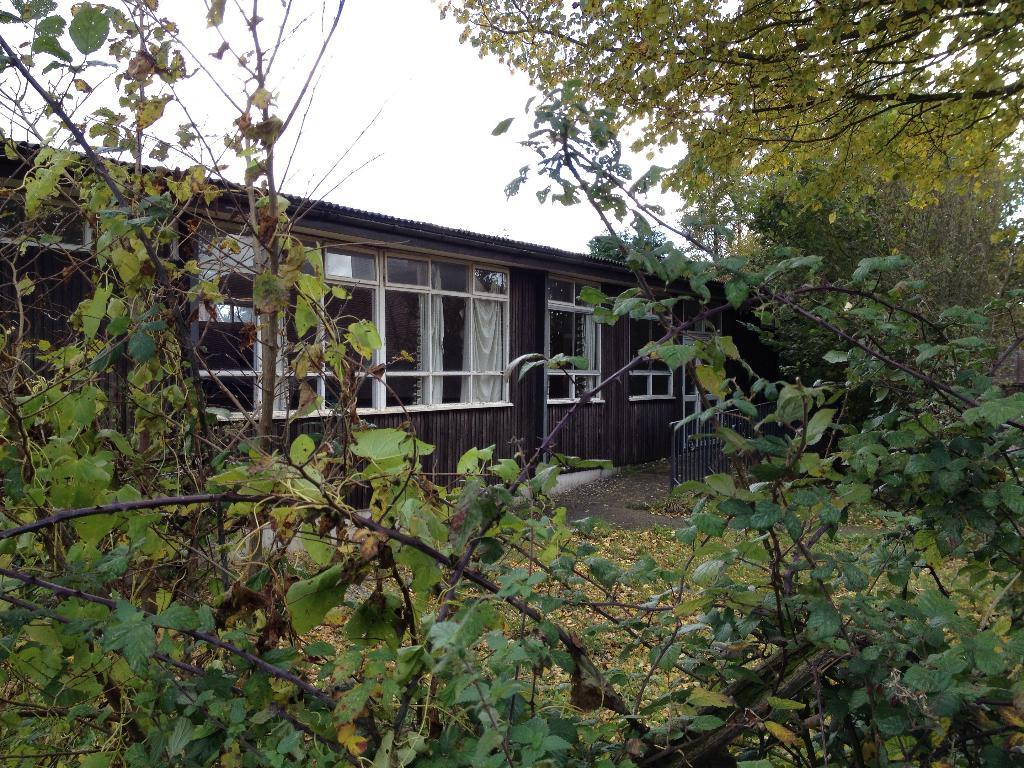What type of vegetation can be seen in the image? There are plants and trees in the image. What structure is located in the middle of the image? There is a shelter in the middle of the image. What is visible at the top of the image? The sky is visible at the top of the image. Who is the manager of the island in the image? There is no island or manager present in the image. What type of cub can be seen playing with the plants in the image? There is no cub present in the image; it only features plants, trees, and a shelter. 